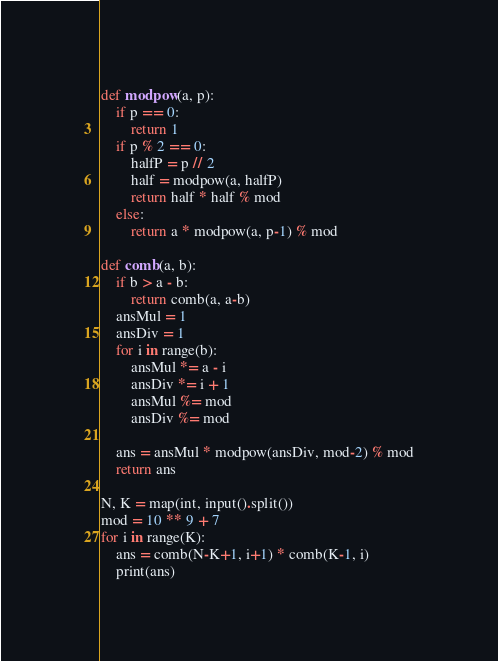<code> <loc_0><loc_0><loc_500><loc_500><_Python_>def modpow(a, p):
    if p == 0:
        return 1
    if p % 2 == 0:
        halfP = p // 2
        half = modpow(a, halfP)
        return half * half % mod
    else:
        return a * modpow(a, p-1) % mod

def comb(a, b):
    if b > a - b:
        return comb(a, a-b)
    ansMul = 1
    ansDiv = 1
    for i in range(b):
        ansMul *= a - i
        ansDiv *= i + 1
        ansMul %= mod
        ansDiv %= mod

    ans = ansMul * modpow(ansDiv, mod-2) % mod
    return ans

N, K = map(int, input().split())
mod = 10 ** 9 + 7
for i in range(K):
    ans = comb(N-K+1, i+1) * comb(K-1, i)
    print(ans)
</code> 